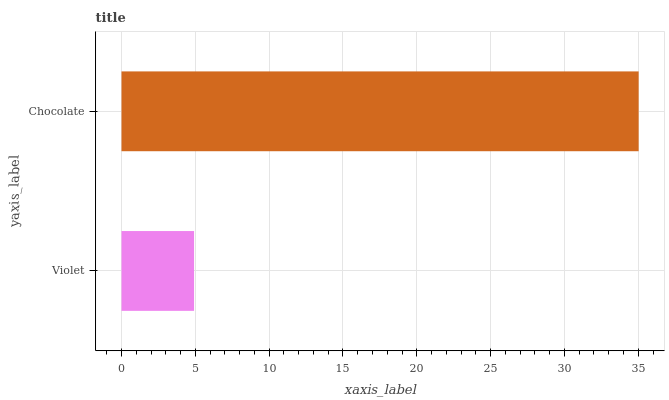Is Violet the minimum?
Answer yes or no. Yes. Is Chocolate the maximum?
Answer yes or no. Yes. Is Chocolate the minimum?
Answer yes or no. No. Is Chocolate greater than Violet?
Answer yes or no. Yes. Is Violet less than Chocolate?
Answer yes or no. Yes. Is Violet greater than Chocolate?
Answer yes or no. No. Is Chocolate less than Violet?
Answer yes or no. No. Is Chocolate the high median?
Answer yes or no. Yes. Is Violet the low median?
Answer yes or no. Yes. Is Violet the high median?
Answer yes or no. No. Is Chocolate the low median?
Answer yes or no. No. 